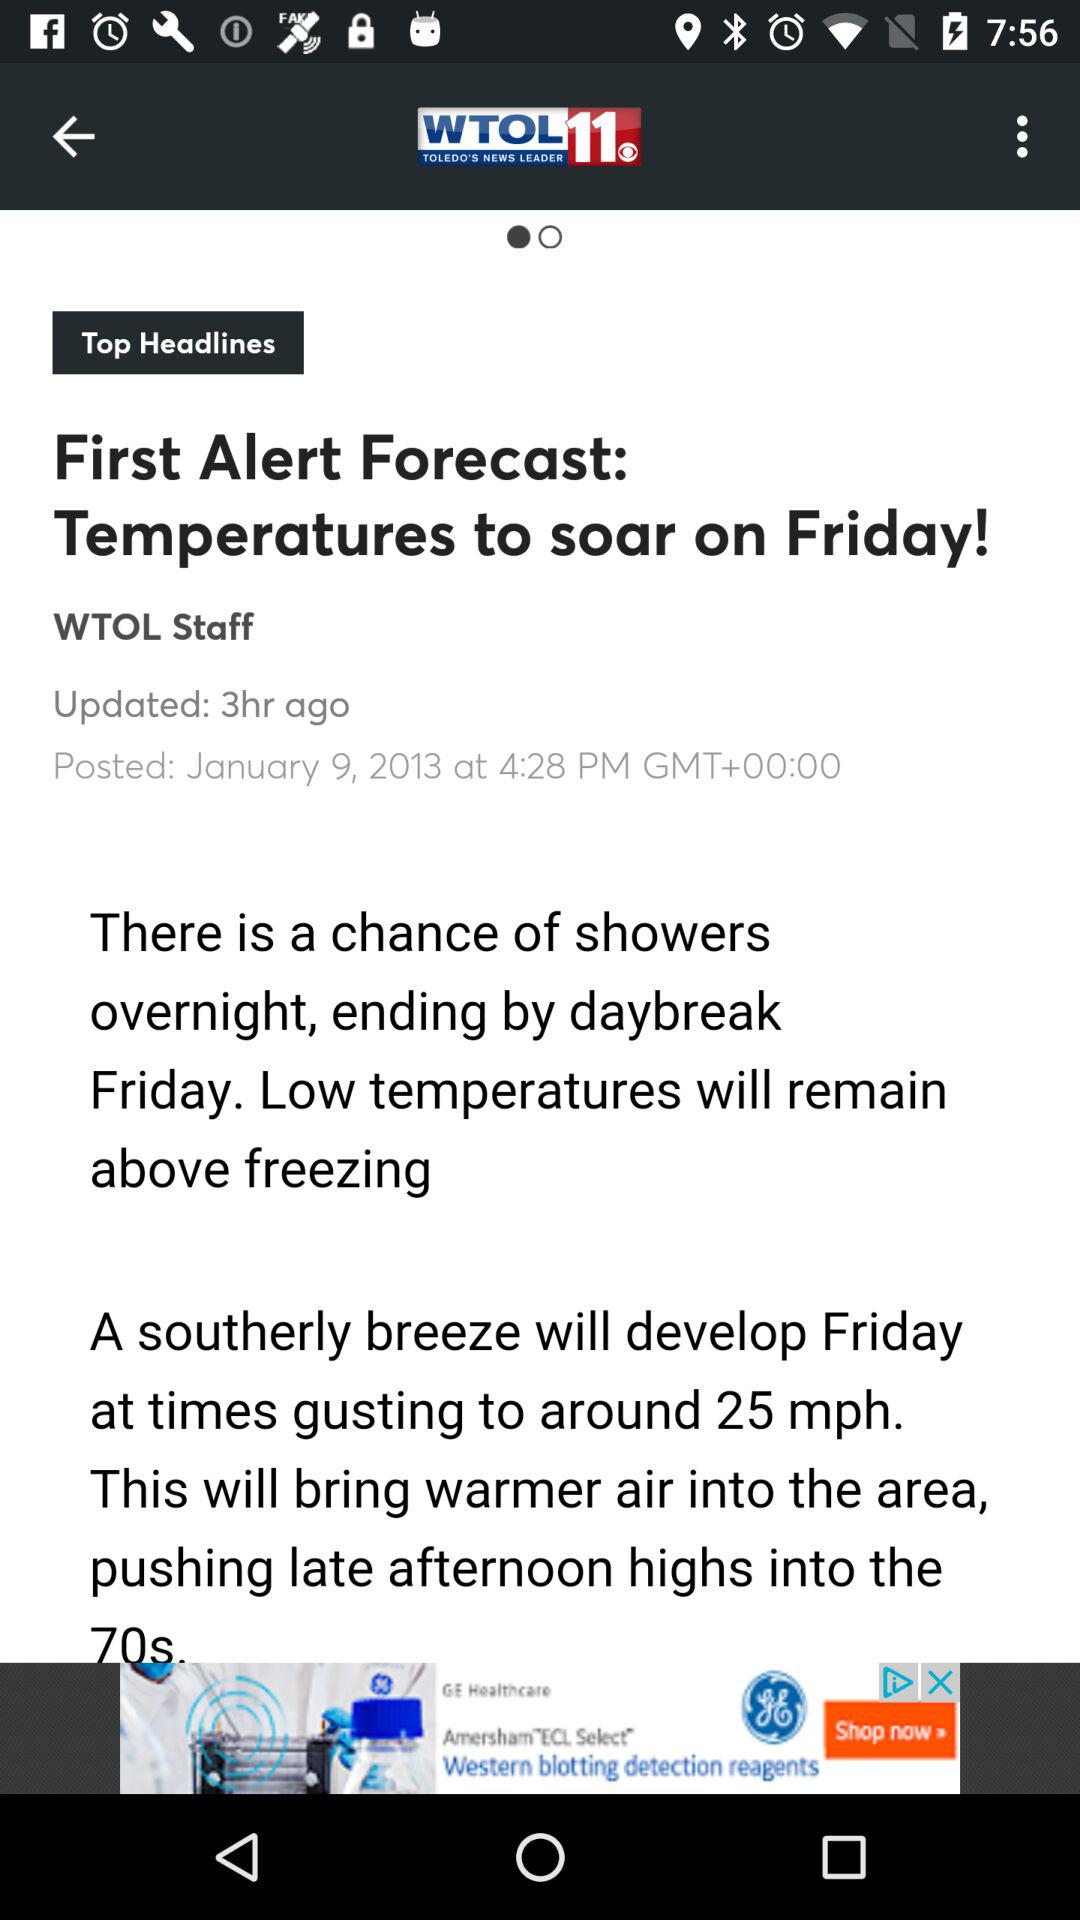What is the time? The time is 4:28 p.m. GMT+00:00. 